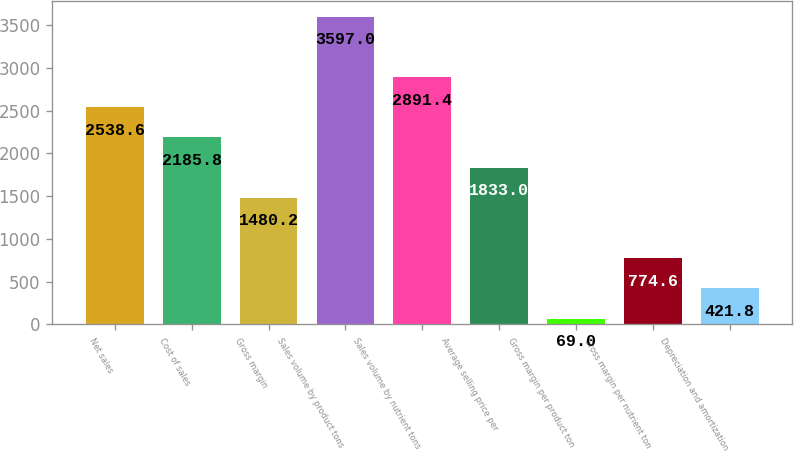<chart> <loc_0><loc_0><loc_500><loc_500><bar_chart><fcel>Net sales<fcel>Cost of sales<fcel>Gross margin<fcel>Sales volume by product tons<fcel>Sales volume by nutrient tons<fcel>Average selling price per<fcel>Gross margin per product ton<fcel>Gross margin per nutrient ton<fcel>Depreciation and amortization<nl><fcel>2538.6<fcel>2185.8<fcel>1480.2<fcel>3597<fcel>2891.4<fcel>1833<fcel>69<fcel>774.6<fcel>421.8<nl></chart> 